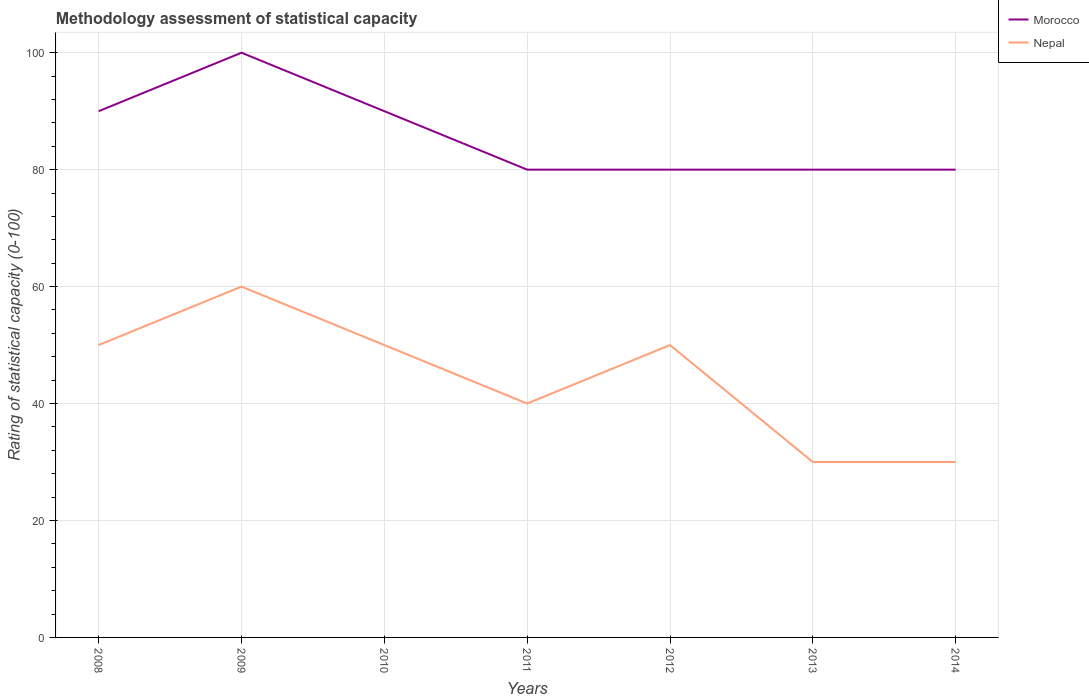Across all years, what is the maximum rating of statistical capacity in Morocco?
Give a very brief answer. 80. What is the total rating of statistical capacity in Nepal in the graph?
Ensure brevity in your answer.  -10. What is the difference between the highest and the second highest rating of statistical capacity in Morocco?
Keep it short and to the point. 20. What is the difference between the highest and the lowest rating of statistical capacity in Nepal?
Provide a succinct answer. 4. Does the graph contain grids?
Your answer should be compact. Yes. How are the legend labels stacked?
Keep it short and to the point. Vertical. What is the title of the graph?
Offer a terse response. Methodology assessment of statistical capacity. What is the label or title of the Y-axis?
Provide a short and direct response. Rating of statistical capacity (0-100). What is the Rating of statistical capacity (0-100) in Nepal in 2008?
Provide a succinct answer. 50. What is the Rating of statistical capacity (0-100) in Nepal in 2009?
Provide a succinct answer. 60. What is the Rating of statistical capacity (0-100) in Morocco in 2010?
Offer a very short reply. 90. What is the Rating of statistical capacity (0-100) of Nepal in 2010?
Provide a succinct answer. 50. What is the Rating of statistical capacity (0-100) of Nepal in 2011?
Your answer should be very brief. 40. What is the Rating of statistical capacity (0-100) in Morocco in 2012?
Ensure brevity in your answer.  80. What is the Rating of statistical capacity (0-100) in Morocco in 2014?
Your response must be concise. 80. What is the Rating of statistical capacity (0-100) in Nepal in 2014?
Your answer should be very brief. 30. Across all years, what is the maximum Rating of statistical capacity (0-100) of Nepal?
Provide a succinct answer. 60. What is the total Rating of statistical capacity (0-100) of Morocco in the graph?
Your answer should be very brief. 600. What is the total Rating of statistical capacity (0-100) in Nepal in the graph?
Your answer should be compact. 310. What is the difference between the Rating of statistical capacity (0-100) in Morocco in 2008 and that in 2009?
Offer a terse response. -10. What is the difference between the Rating of statistical capacity (0-100) in Nepal in 2008 and that in 2009?
Keep it short and to the point. -10. What is the difference between the Rating of statistical capacity (0-100) of Morocco in 2008 and that in 2010?
Offer a terse response. 0. What is the difference between the Rating of statistical capacity (0-100) of Nepal in 2008 and that in 2010?
Give a very brief answer. 0. What is the difference between the Rating of statistical capacity (0-100) in Morocco in 2008 and that in 2011?
Make the answer very short. 10. What is the difference between the Rating of statistical capacity (0-100) of Nepal in 2008 and that in 2011?
Give a very brief answer. 10. What is the difference between the Rating of statistical capacity (0-100) of Morocco in 2008 and that in 2012?
Make the answer very short. 10. What is the difference between the Rating of statistical capacity (0-100) in Morocco in 2008 and that in 2013?
Make the answer very short. 10. What is the difference between the Rating of statistical capacity (0-100) in Nepal in 2008 and that in 2013?
Give a very brief answer. 20. What is the difference between the Rating of statistical capacity (0-100) of Nepal in 2009 and that in 2010?
Your response must be concise. 10. What is the difference between the Rating of statistical capacity (0-100) in Morocco in 2009 and that in 2011?
Ensure brevity in your answer.  20. What is the difference between the Rating of statistical capacity (0-100) in Nepal in 2009 and that in 2011?
Ensure brevity in your answer.  20. What is the difference between the Rating of statistical capacity (0-100) in Nepal in 2009 and that in 2012?
Ensure brevity in your answer.  10. What is the difference between the Rating of statistical capacity (0-100) in Morocco in 2010 and that in 2011?
Offer a terse response. 10. What is the difference between the Rating of statistical capacity (0-100) of Nepal in 2010 and that in 2012?
Provide a short and direct response. 0. What is the difference between the Rating of statistical capacity (0-100) of Nepal in 2010 and that in 2013?
Provide a short and direct response. 20. What is the difference between the Rating of statistical capacity (0-100) of Morocco in 2010 and that in 2014?
Offer a terse response. 10. What is the difference between the Rating of statistical capacity (0-100) in Nepal in 2011 and that in 2012?
Ensure brevity in your answer.  -10. What is the difference between the Rating of statistical capacity (0-100) of Morocco in 2011 and that in 2013?
Ensure brevity in your answer.  0. What is the difference between the Rating of statistical capacity (0-100) in Nepal in 2011 and that in 2014?
Offer a very short reply. 10. What is the difference between the Rating of statistical capacity (0-100) of Morocco in 2012 and that in 2013?
Offer a terse response. 0. What is the difference between the Rating of statistical capacity (0-100) of Morocco in 2012 and that in 2014?
Make the answer very short. 0. What is the difference between the Rating of statistical capacity (0-100) of Nepal in 2012 and that in 2014?
Your response must be concise. 20. What is the difference between the Rating of statistical capacity (0-100) in Nepal in 2013 and that in 2014?
Your answer should be very brief. 0. What is the difference between the Rating of statistical capacity (0-100) in Morocco in 2008 and the Rating of statistical capacity (0-100) in Nepal in 2009?
Your answer should be very brief. 30. What is the difference between the Rating of statistical capacity (0-100) of Morocco in 2008 and the Rating of statistical capacity (0-100) of Nepal in 2010?
Offer a very short reply. 40. What is the difference between the Rating of statistical capacity (0-100) of Morocco in 2008 and the Rating of statistical capacity (0-100) of Nepal in 2011?
Your answer should be compact. 50. What is the difference between the Rating of statistical capacity (0-100) of Morocco in 2008 and the Rating of statistical capacity (0-100) of Nepal in 2012?
Ensure brevity in your answer.  40. What is the difference between the Rating of statistical capacity (0-100) of Morocco in 2008 and the Rating of statistical capacity (0-100) of Nepal in 2013?
Offer a very short reply. 60. What is the difference between the Rating of statistical capacity (0-100) of Morocco in 2009 and the Rating of statistical capacity (0-100) of Nepal in 2013?
Offer a terse response. 70. What is the difference between the Rating of statistical capacity (0-100) of Morocco in 2009 and the Rating of statistical capacity (0-100) of Nepal in 2014?
Give a very brief answer. 70. What is the difference between the Rating of statistical capacity (0-100) of Morocco in 2011 and the Rating of statistical capacity (0-100) of Nepal in 2012?
Offer a terse response. 30. What is the difference between the Rating of statistical capacity (0-100) of Morocco in 2011 and the Rating of statistical capacity (0-100) of Nepal in 2014?
Your response must be concise. 50. What is the average Rating of statistical capacity (0-100) in Morocco per year?
Offer a very short reply. 85.71. What is the average Rating of statistical capacity (0-100) in Nepal per year?
Offer a very short reply. 44.29. In the year 2010, what is the difference between the Rating of statistical capacity (0-100) in Morocco and Rating of statistical capacity (0-100) in Nepal?
Ensure brevity in your answer.  40. In the year 2011, what is the difference between the Rating of statistical capacity (0-100) in Morocco and Rating of statistical capacity (0-100) in Nepal?
Your answer should be very brief. 40. In the year 2012, what is the difference between the Rating of statistical capacity (0-100) in Morocco and Rating of statistical capacity (0-100) in Nepal?
Ensure brevity in your answer.  30. In the year 2013, what is the difference between the Rating of statistical capacity (0-100) in Morocco and Rating of statistical capacity (0-100) in Nepal?
Offer a very short reply. 50. What is the ratio of the Rating of statistical capacity (0-100) in Morocco in 2008 to that in 2009?
Provide a short and direct response. 0.9. What is the ratio of the Rating of statistical capacity (0-100) in Nepal in 2008 to that in 2009?
Give a very brief answer. 0.83. What is the ratio of the Rating of statistical capacity (0-100) in Morocco in 2008 to that in 2010?
Give a very brief answer. 1. What is the ratio of the Rating of statistical capacity (0-100) of Nepal in 2008 to that in 2011?
Provide a succinct answer. 1.25. What is the ratio of the Rating of statistical capacity (0-100) in Morocco in 2008 to that in 2012?
Ensure brevity in your answer.  1.12. What is the ratio of the Rating of statistical capacity (0-100) of Nepal in 2008 to that in 2012?
Provide a succinct answer. 1. What is the ratio of the Rating of statistical capacity (0-100) in Morocco in 2008 to that in 2013?
Provide a succinct answer. 1.12. What is the ratio of the Rating of statistical capacity (0-100) of Nepal in 2008 to that in 2013?
Your answer should be compact. 1.67. What is the ratio of the Rating of statistical capacity (0-100) in Morocco in 2008 to that in 2014?
Provide a succinct answer. 1.12. What is the ratio of the Rating of statistical capacity (0-100) of Nepal in 2008 to that in 2014?
Provide a short and direct response. 1.67. What is the ratio of the Rating of statistical capacity (0-100) in Morocco in 2009 to that in 2011?
Provide a short and direct response. 1.25. What is the ratio of the Rating of statistical capacity (0-100) of Nepal in 2009 to that in 2011?
Offer a very short reply. 1.5. What is the ratio of the Rating of statistical capacity (0-100) in Nepal in 2009 to that in 2013?
Provide a short and direct response. 2. What is the ratio of the Rating of statistical capacity (0-100) in Nepal in 2009 to that in 2014?
Your response must be concise. 2. What is the ratio of the Rating of statistical capacity (0-100) in Morocco in 2010 to that in 2014?
Your response must be concise. 1.12. What is the ratio of the Rating of statistical capacity (0-100) in Nepal in 2011 to that in 2012?
Keep it short and to the point. 0.8. What is the ratio of the Rating of statistical capacity (0-100) of Nepal in 2011 to that in 2013?
Provide a succinct answer. 1.33. What is the ratio of the Rating of statistical capacity (0-100) in Nepal in 2011 to that in 2014?
Give a very brief answer. 1.33. What is the ratio of the Rating of statistical capacity (0-100) in Nepal in 2012 to that in 2014?
Give a very brief answer. 1.67. What is the ratio of the Rating of statistical capacity (0-100) in Morocco in 2013 to that in 2014?
Keep it short and to the point. 1. What is the ratio of the Rating of statistical capacity (0-100) of Nepal in 2013 to that in 2014?
Provide a succinct answer. 1. What is the difference between the highest and the second highest Rating of statistical capacity (0-100) in Nepal?
Your response must be concise. 10. What is the difference between the highest and the lowest Rating of statistical capacity (0-100) in Morocco?
Provide a succinct answer. 20. 